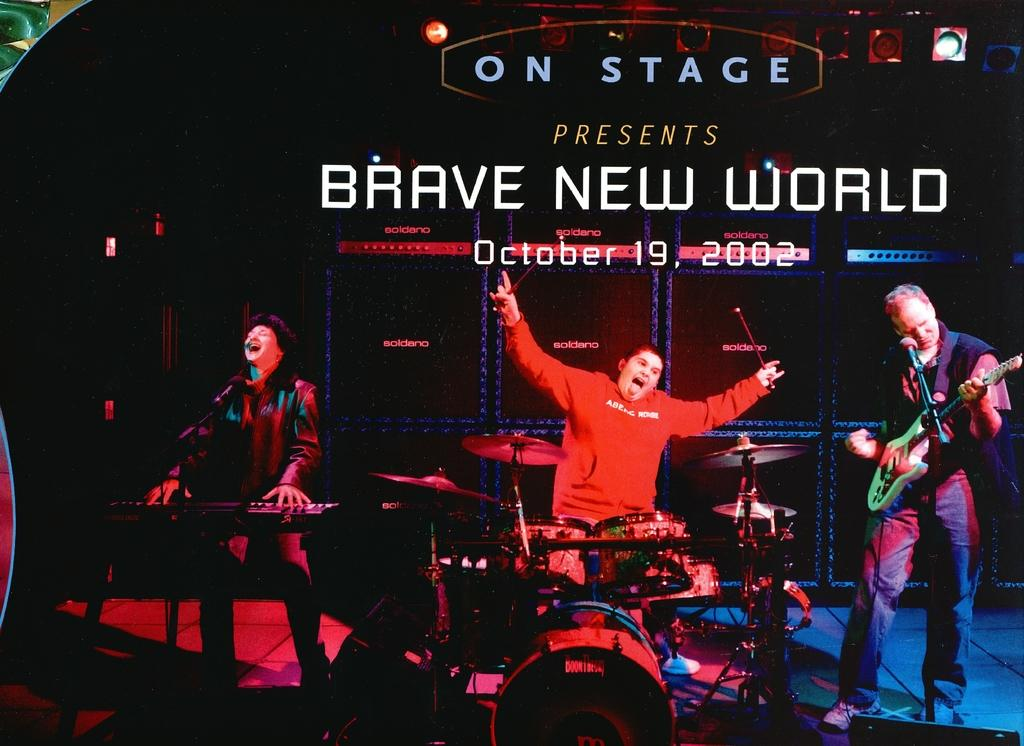What are the people in the image doing? The people in the image are standing. What instrument is the man holding? The man is holding a guitar. What equipment is present for amplifying sound in the image? There is a microphone (mic) in the image. What other musical instruments can be seen in the image? There is a drum set and a musical keyboard in the image. What type of account is the man trying to open with the badge in the image? There is no account or badge present in the image. 